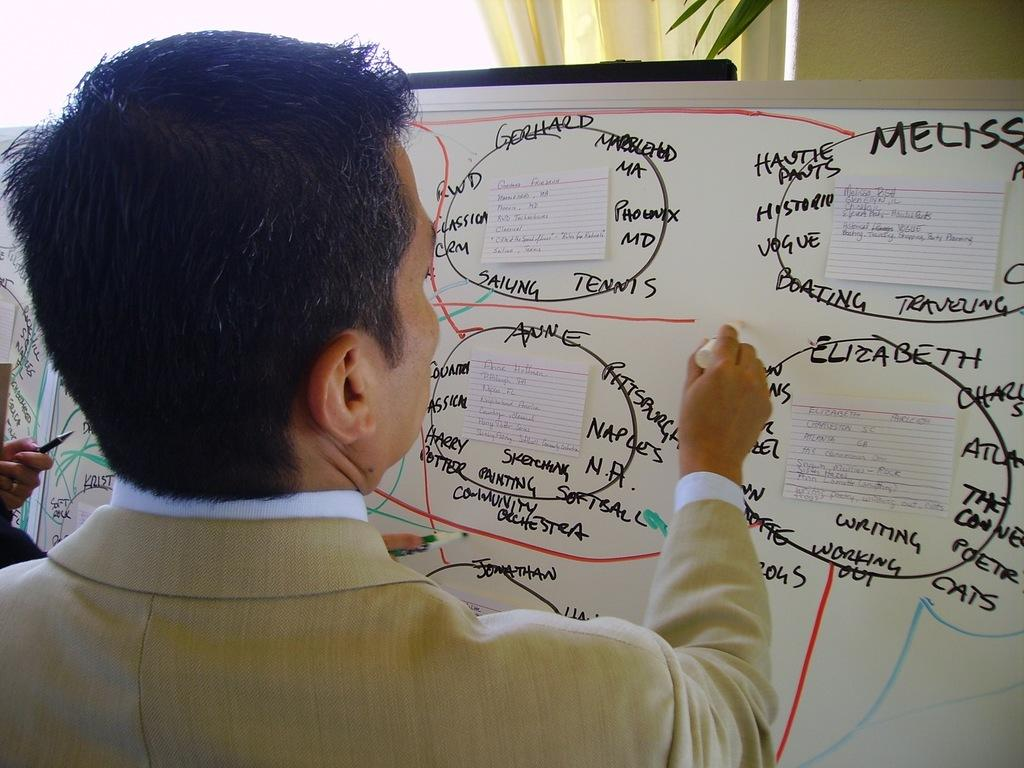<image>
Provide a brief description of the given image. A man writes on a whiteboard which appears to spell out who likes what. 